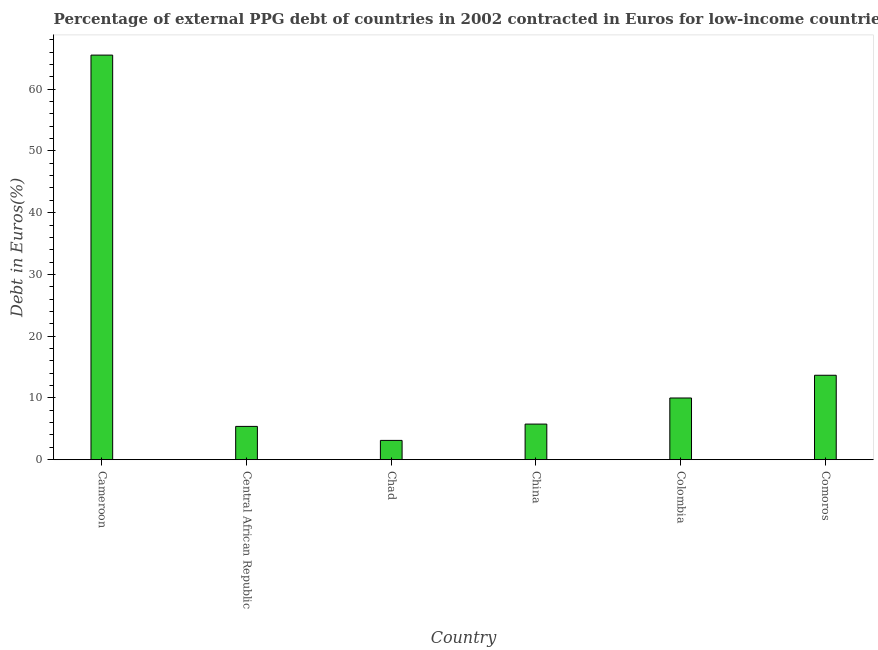Does the graph contain grids?
Provide a succinct answer. No. What is the title of the graph?
Make the answer very short. Percentage of external PPG debt of countries in 2002 contracted in Euros for low-income countries. What is the label or title of the X-axis?
Offer a terse response. Country. What is the label or title of the Y-axis?
Your answer should be compact. Debt in Euros(%). What is the currency composition of ppg debt in Chad?
Give a very brief answer. 3.12. Across all countries, what is the maximum currency composition of ppg debt?
Offer a very short reply. 65.51. Across all countries, what is the minimum currency composition of ppg debt?
Your answer should be compact. 3.12. In which country was the currency composition of ppg debt maximum?
Keep it short and to the point. Cameroon. In which country was the currency composition of ppg debt minimum?
Keep it short and to the point. Chad. What is the sum of the currency composition of ppg debt?
Keep it short and to the point. 103.45. What is the difference between the currency composition of ppg debt in Chad and Comoros?
Provide a short and direct response. -10.55. What is the average currency composition of ppg debt per country?
Give a very brief answer. 17.24. What is the median currency composition of ppg debt?
Your response must be concise. 7.88. What is the ratio of the currency composition of ppg debt in Cameroon to that in China?
Keep it short and to the point. 11.36. Is the currency composition of ppg debt in Central African Republic less than that in Comoros?
Provide a short and direct response. Yes. What is the difference between the highest and the second highest currency composition of ppg debt?
Offer a very short reply. 51.84. Is the sum of the currency composition of ppg debt in Cameroon and Comoros greater than the maximum currency composition of ppg debt across all countries?
Your answer should be very brief. Yes. What is the difference between the highest and the lowest currency composition of ppg debt?
Offer a terse response. 62.39. In how many countries, is the currency composition of ppg debt greater than the average currency composition of ppg debt taken over all countries?
Offer a very short reply. 1. Are all the bars in the graph horizontal?
Provide a succinct answer. No. What is the Debt in Euros(%) of Cameroon?
Ensure brevity in your answer.  65.51. What is the Debt in Euros(%) in Central African Republic?
Offer a very short reply. 5.39. What is the Debt in Euros(%) in Chad?
Your answer should be compact. 3.12. What is the Debt in Euros(%) of China?
Provide a succinct answer. 5.77. What is the Debt in Euros(%) of Colombia?
Your answer should be compact. 9.99. What is the Debt in Euros(%) in Comoros?
Offer a very short reply. 13.67. What is the difference between the Debt in Euros(%) in Cameroon and Central African Republic?
Your answer should be very brief. 60.12. What is the difference between the Debt in Euros(%) in Cameroon and Chad?
Ensure brevity in your answer.  62.39. What is the difference between the Debt in Euros(%) in Cameroon and China?
Your answer should be compact. 59.74. What is the difference between the Debt in Euros(%) in Cameroon and Colombia?
Your answer should be very brief. 55.52. What is the difference between the Debt in Euros(%) in Cameroon and Comoros?
Your answer should be compact. 51.84. What is the difference between the Debt in Euros(%) in Central African Republic and Chad?
Keep it short and to the point. 2.27. What is the difference between the Debt in Euros(%) in Central African Republic and China?
Offer a terse response. -0.38. What is the difference between the Debt in Euros(%) in Central African Republic and Colombia?
Offer a terse response. -4.6. What is the difference between the Debt in Euros(%) in Central African Republic and Comoros?
Your answer should be compact. -8.28. What is the difference between the Debt in Euros(%) in Chad and China?
Provide a short and direct response. -2.64. What is the difference between the Debt in Euros(%) in Chad and Colombia?
Ensure brevity in your answer.  -6.87. What is the difference between the Debt in Euros(%) in Chad and Comoros?
Your answer should be compact. -10.55. What is the difference between the Debt in Euros(%) in China and Colombia?
Offer a terse response. -4.22. What is the difference between the Debt in Euros(%) in China and Comoros?
Offer a very short reply. -7.91. What is the difference between the Debt in Euros(%) in Colombia and Comoros?
Offer a very short reply. -3.68. What is the ratio of the Debt in Euros(%) in Cameroon to that in Central African Republic?
Your answer should be compact. 12.15. What is the ratio of the Debt in Euros(%) in Cameroon to that in Chad?
Your answer should be compact. 20.97. What is the ratio of the Debt in Euros(%) in Cameroon to that in China?
Provide a short and direct response. 11.36. What is the ratio of the Debt in Euros(%) in Cameroon to that in Colombia?
Ensure brevity in your answer.  6.56. What is the ratio of the Debt in Euros(%) in Cameroon to that in Comoros?
Your answer should be compact. 4.79. What is the ratio of the Debt in Euros(%) in Central African Republic to that in Chad?
Your answer should be compact. 1.73. What is the ratio of the Debt in Euros(%) in Central African Republic to that in China?
Keep it short and to the point. 0.94. What is the ratio of the Debt in Euros(%) in Central African Republic to that in Colombia?
Offer a terse response. 0.54. What is the ratio of the Debt in Euros(%) in Central African Republic to that in Comoros?
Offer a terse response. 0.39. What is the ratio of the Debt in Euros(%) in Chad to that in China?
Provide a succinct answer. 0.54. What is the ratio of the Debt in Euros(%) in Chad to that in Colombia?
Ensure brevity in your answer.  0.31. What is the ratio of the Debt in Euros(%) in Chad to that in Comoros?
Give a very brief answer. 0.23. What is the ratio of the Debt in Euros(%) in China to that in Colombia?
Your answer should be very brief. 0.58. What is the ratio of the Debt in Euros(%) in China to that in Comoros?
Offer a terse response. 0.42. What is the ratio of the Debt in Euros(%) in Colombia to that in Comoros?
Your answer should be very brief. 0.73. 